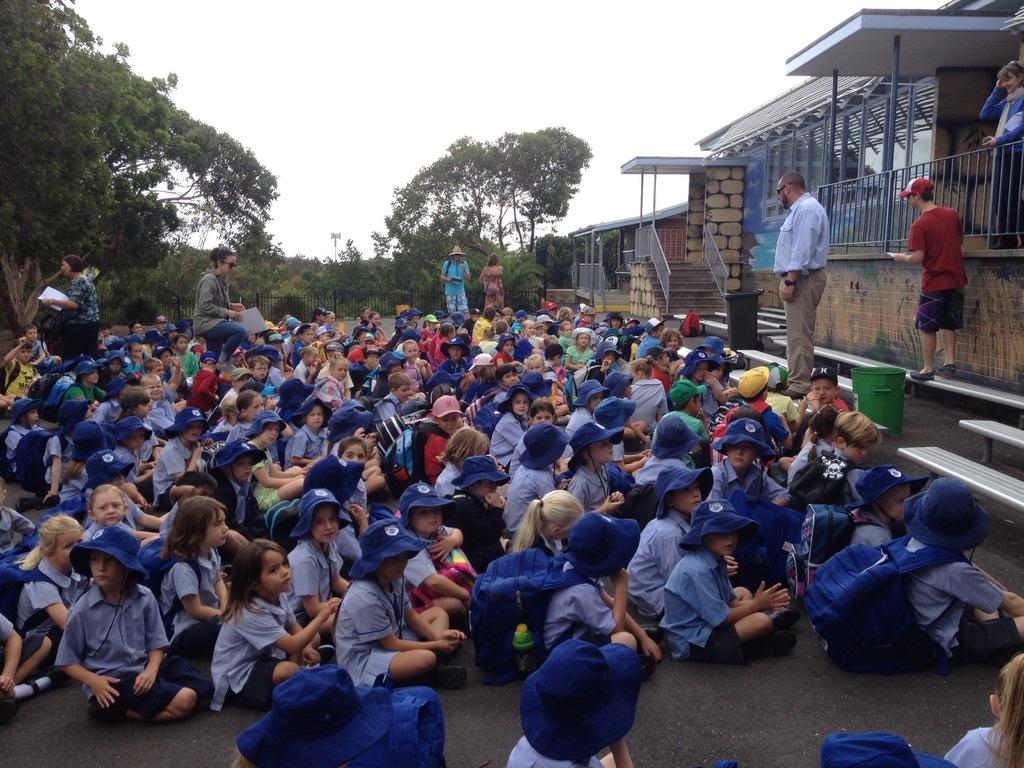What are the children doing in the image? The children are sitting on the road in the image. What is located in front of the children? There is a building and a dustbin in front of the children. Are there any other people present in the image? Yes, there are people standing near the children. What can be seen behind the children? There are trees behind the children. How many screws can be seen on the children's clothing in the image? There are no screws visible on the children's clothing in the image. What historical event is being commemorated in the image? There is no indication of a historical event being commemorated in the image. 